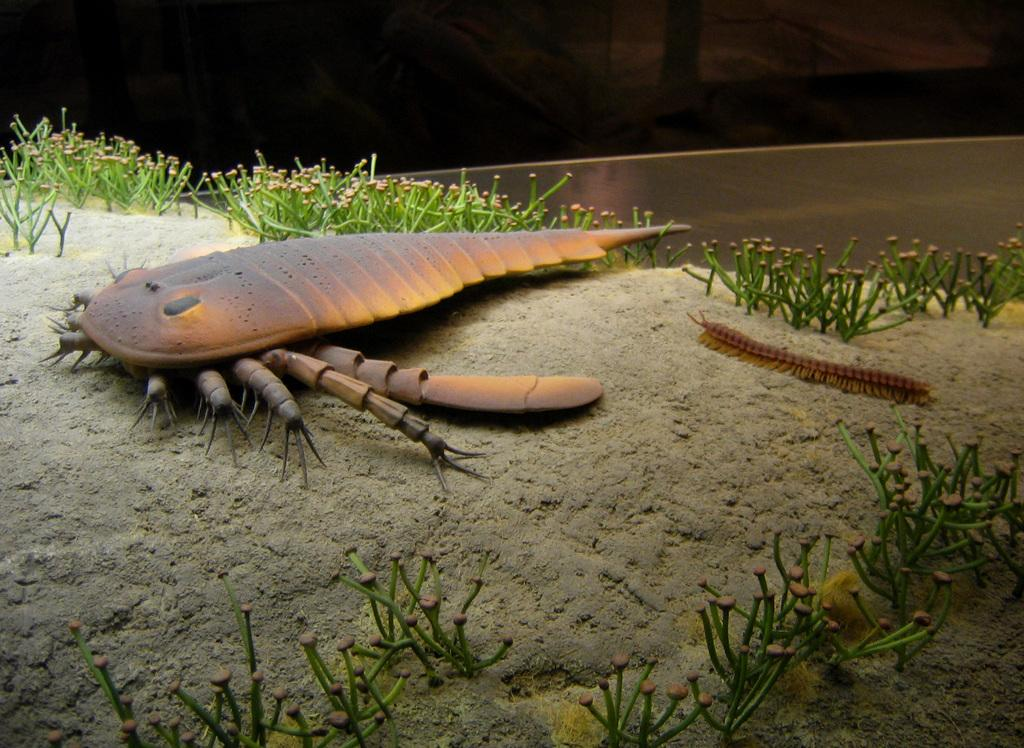What can be seen in the front of the image? There are insects and plants in the front of the image. Can you describe the insects in the image? The insects in the image are not specified, but they are present in the front. What is the color of the background in the image? The background of the image is dark. What songs are the insects singing in the image? There is no indication in the image that the insects are singing songs, so it cannot be determined from the picture. 